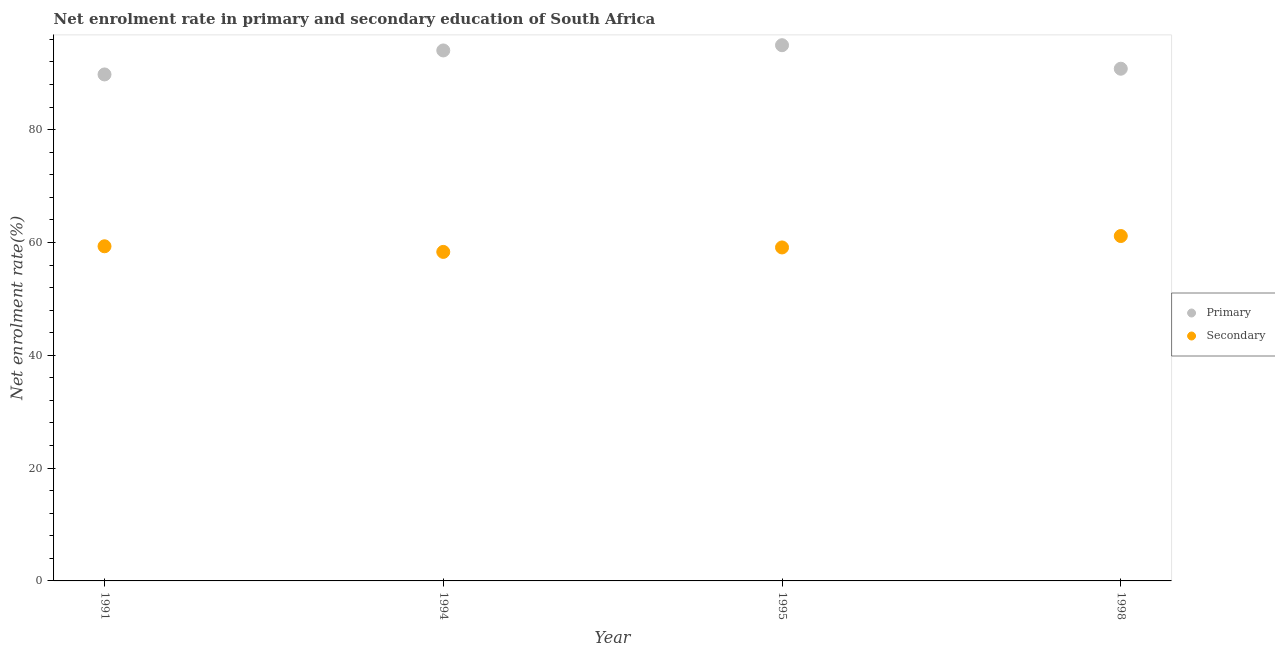How many different coloured dotlines are there?
Offer a terse response. 2. What is the enrollment rate in primary education in 1991?
Make the answer very short. 89.78. Across all years, what is the maximum enrollment rate in secondary education?
Ensure brevity in your answer.  61.14. Across all years, what is the minimum enrollment rate in secondary education?
Make the answer very short. 58.32. In which year was the enrollment rate in primary education maximum?
Your response must be concise. 1995. In which year was the enrollment rate in secondary education minimum?
Make the answer very short. 1994. What is the total enrollment rate in primary education in the graph?
Provide a short and direct response. 369.57. What is the difference between the enrollment rate in primary education in 1991 and that in 1995?
Your answer should be very brief. -5.18. What is the difference between the enrollment rate in primary education in 1998 and the enrollment rate in secondary education in 1995?
Offer a terse response. 31.68. What is the average enrollment rate in secondary education per year?
Keep it short and to the point. 59.47. In the year 1991, what is the difference between the enrollment rate in primary education and enrollment rate in secondary education?
Your answer should be compact. 30.46. In how many years, is the enrollment rate in primary education greater than 40 %?
Give a very brief answer. 4. What is the ratio of the enrollment rate in primary education in 1991 to that in 1995?
Keep it short and to the point. 0.95. Is the enrollment rate in primary education in 1994 less than that in 1995?
Provide a short and direct response. Yes. What is the difference between the highest and the second highest enrollment rate in primary education?
Give a very brief answer. 0.93. What is the difference between the highest and the lowest enrollment rate in primary education?
Your response must be concise. 5.18. In how many years, is the enrollment rate in secondary education greater than the average enrollment rate in secondary education taken over all years?
Offer a terse response. 1. Is the enrollment rate in secondary education strictly greater than the enrollment rate in primary education over the years?
Keep it short and to the point. No. Is the enrollment rate in secondary education strictly less than the enrollment rate in primary education over the years?
Keep it short and to the point. Yes. Are the values on the major ticks of Y-axis written in scientific E-notation?
Your response must be concise. No. Does the graph contain any zero values?
Keep it short and to the point. No. Does the graph contain grids?
Provide a succinct answer. No. How are the legend labels stacked?
Your answer should be very brief. Vertical. What is the title of the graph?
Offer a very short reply. Net enrolment rate in primary and secondary education of South Africa. Does "% of GNI" appear as one of the legend labels in the graph?
Provide a short and direct response. No. What is the label or title of the Y-axis?
Provide a succinct answer. Net enrolment rate(%). What is the Net enrolment rate(%) in Primary in 1991?
Offer a terse response. 89.78. What is the Net enrolment rate(%) of Secondary in 1991?
Provide a succinct answer. 59.32. What is the Net enrolment rate(%) in Primary in 1994?
Give a very brief answer. 94.03. What is the Net enrolment rate(%) in Secondary in 1994?
Offer a very short reply. 58.32. What is the Net enrolment rate(%) in Primary in 1995?
Provide a succinct answer. 94.96. What is the Net enrolment rate(%) in Secondary in 1995?
Ensure brevity in your answer.  59.11. What is the Net enrolment rate(%) in Primary in 1998?
Your answer should be compact. 90.79. What is the Net enrolment rate(%) of Secondary in 1998?
Your response must be concise. 61.14. Across all years, what is the maximum Net enrolment rate(%) in Primary?
Keep it short and to the point. 94.96. Across all years, what is the maximum Net enrolment rate(%) of Secondary?
Offer a very short reply. 61.14. Across all years, what is the minimum Net enrolment rate(%) in Primary?
Provide a short and direct response. 89.78. Across all years, what is the minimum Net enrolment rate(%) in Secondary?
Your answer should be very brief. 58.32. What is the total Net enrolment rate(%) of Primary in the graph?
Your answer should be very brief. 369.57. What is the total Net enrolment rate(%) in Secondary in the graph?
Your response must be concise. 237.89. What is the difference between the Net enrolment rate(%) in Primary in 1991 and that in 1994?
Your answer should be compact. -4.25. What is the difference between the Net enrolment rate(%) in Primary in 1991 and that in 1995?
Provide a short and direct response. -5.18. What is the difference between the Net enrolment rate(%) of Secondary in 1991 and that in 1995?
Keep it short and to the point. 0.21. What is the difference between the Net enrolment rate(%) of Primary in 1991 and that in 1998?
Provide a short and direct response. -1.01. What is the difference between the Net enrolment rate(%) of Secondary in 1991 and that in 1998?
Provide a short and direct response. -1.82. What is the difference between the Net enrolment rate(%) in Primary in 1994 and that in 1995?
Your answer should be very brief. -0.93. What is the difference between the Net enrolment rate(%) in Secondary in 1994 and that in 1995?
Provide a short and direct response. -0.79. What is the difference between the Net enrolment rate(%) of Primary in 1994 and that in 1998?
Provide a short and direct response. 3.24. What is the difference between the Net enrolment rate(%) of Secondary in 1994 and that in 1998?
Keep it short and to the point. -2.81. What is the difference between the Net enrolment rate(%) of Primary in 1995 and that in 1998?
Offer a very short reply. 4.17. What is the difference between the Net enrolment rate(%) of Secondary in 1995 and that in 1998?
Make the answer very short. -2.02. What is the difference between the Net enrolment rate(%) of Primary in 1991 and the Net enrolment rate(%) of Secondary in 1994?
Keep it short and to the point. 31.46. What is the difference between the Net enrolment rate(%) in Primary in 1991 and the Net enrolment rate(%) in Secondary in 1995?
Your response must be concise. 30.67. What is the difference between the Net enrolment rate(%) in Primary in 1991 and the Net enrolment rate(%) in Secondary in 1998?
Give a very brief answer. 28.64. What is the difference between the Net enrolment rate(%) in Primary in 1994 and the Net enrolment rate(%) in Secondary in 1995?
Provide a short and direct response. 34.92. What is the difference between the Net enrolment rate(%) of Primary in 1994 and the Net enrolment rate(%) of Secondary in 1998?
Keep it short and to the point. 32.9. What is the difference between the Net enrolment rate(%) of Primary in 1995 and the Net enrolment rate(%) of Secondary in 1998?
Your answer should be compact. 33.82. What is the average Net enrolment rate(%) in Primary per year?
Provide a short and direct response. 92.39. What is the average Net enrolment rate(%) of Secondary per year?
Provide a short and direct response. 59.47. In the year 1991, what is the difference between the Net enrolment rate(%) in Primary and Net enrolment rate(%) in Secondary?
Your response must be concise. 30.46. In the year 1994, what is the difference between the Net enrolment rate(%) of Primary and Net enrolment rate(%) of Secondary?
Provide a short and direct response. 35.71. In the year 1995, what is the difference between the Net enrolment rate(%) in Primary and Net enrolment rate(%) in Secondary?
Provide a short and direct response. 35.85. In the year 1998, what is the difference between the Net enrolment rate(%) in Primary and Net enrolment rate(%) in Secondary?
Provide a short and direct response. 29.66. What is the ratio of the Net enrolment rate(%) in Primary in 1991 to that in 1994?
Your answer should be compact. 0.95. What is the ratio of the Net enrolment rate(%) of Secondary in 1991 to that in 1994?
Offer a very short reply. 1.02. What is the ratio of the Net enrolment rate(%) in Primary in 1991 to that in 1995?
Keep it short and to the point. 0.95. What is the ratio of the Net enrolment rate(%) in Secondary in 1991 to that in 1995?
Ensure brevity in your answer.  1. What is the ratio of the Net enrolment rate(%) of Secondary in 1991 to that in 1998?
Offer a very short reply. 0.97. What is the ratio of the Net enrolment rate(%) in Primary in 1994 to that in 1995?
Offer a very short reply. 0.99. What is the ratio of the Net enrolment rate(%) in Secondary in 1994 to that in 1995?
Offer a terse response. 0.99. What is the ratio of the Net enrolment rate(%) in Primary in 1994 to that in 1998?
Provide a succinct answer. 1.04. What is the ratio of the Net enrolment rate(%) of Secondary in 1994 to that in 1998?
Keep it short and to the point. 0.95. What is the ratio of the Net enrolment rate(%) in Primary in 1995 to that in 1998?
Provide a short and direct response. 1.05. What is the ratio of the Net enrolment rate(%) in Secondary in 1995 to that in 1998?
Give a very brief answer. 0.97. What is the difference between the highest and the second highest Net enrolment rate(%) in Primary?
Provide a succinct answer. 0.93. What is the difference between the highest and the second highest Net enrolment rate(%) in Secondary?
Your response must be concise. 1.82. What is the difference between the highest and the lowest Net enrolment rate(%) in Primary?
Your response must be concise. 5.18. What is the difference between the highest and the lowest Net enrolment rate(%) of Secondary?
Your answer should be compact. 2.81. 